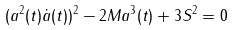Convert formula to latex. <formula><loc_0><loc_0><loc_500><loc_500>( a ^ { 2 } ( t ) \dot { a } ( t ) ) ^ { 2 } - 2 M a ^ { 3 } ( t ) + 3 S ^ { 2 } = 0</formula> 